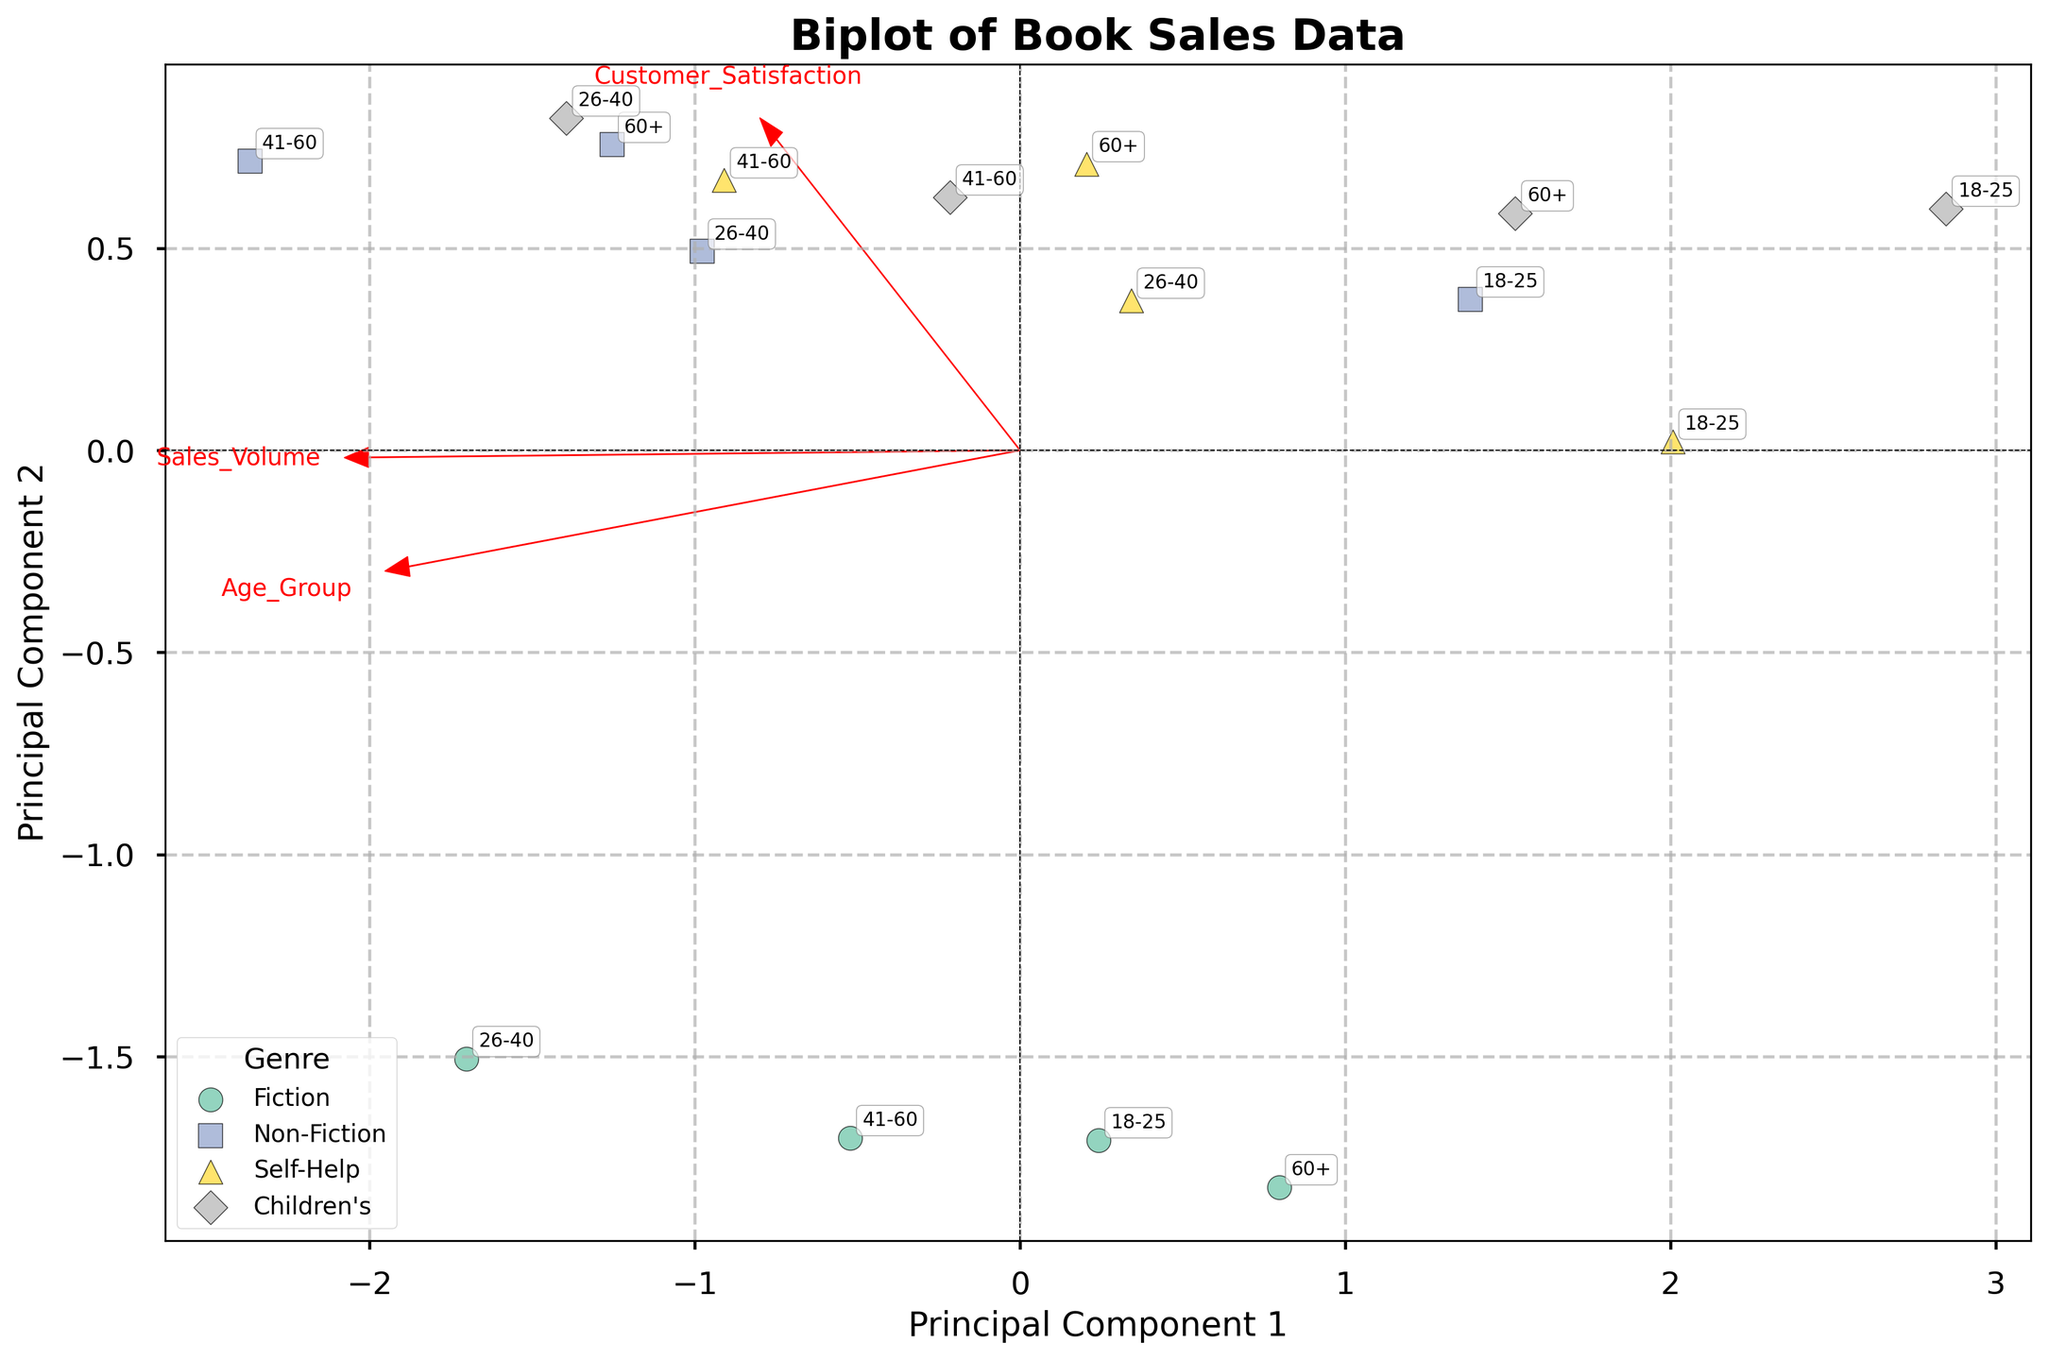What is the title of the plot? The title is located at the top center of the plot in larger, bold font. By reading it, we can directly obtain the title.
Answer: Biplot of Book Sales Data How many unique genres are represented in this plot? The legend on the plot shows each genre with a different color and marker. By counting them, we can determine the number of unique genres.
Answer: 4 Which genre appears to have the highest customer satisfaction across age groups? The position of points representing each genre in relation to the Customer_Satisfaction vector indicates its satisfaction level. The genre closest to the end of the Customer_Satisfaction arrow has the highest satisfaction.
Answer: Non-Fiction Which vector is more correlated with Principal Component 1? By observing the direction and length of the vectors, the one that aligns most closely with the horizontal axis, representing Principal Component 1, is more correlated.
Answer: Sales_Volume What age group is represented by the point closest to the origin? We can identify the point closest to the origin by looking for the one nearest to the intersection of the principal component axes, and then read the age group annotation next to that point.
Answer: 18-25 (Children's) Which age group shows greater sales volume for Fiction compared to 26-40 for Self-Help? By comparing the positions of Fiction and Self-Help points in relation to the Sales_Volume vector, we can determine which age group for Fiction is positioned further along the vector than 26-40 for Self-Help.
Answer: 26-40 (Fiction) What does the arrow representing Customer_Satisfaction indicate about its relationship to Educational_Value? The vectors representing Customer_Satisfaction and Educational_Value can be compared by their orientation. If they point in similar directions, it indicates they have a positive correlation.
Answer: Positive correlation Which data points suggest a lower educational value despite high customer satisfaction? Points far from the Educational_Value vector but near the Customer_Satisfaction vector suggest this trend. Identifying such points and then looking at their annotations indicates the respective genres and age groups.
Answer: Fiction (60+) Which genre and age group combination appears to have both high sales volume and high educational value? We look for points that are positioned high along both the Sales_Volume and Educational_Value vectors, and then check their genre and age group annotations.
Answer: Non-Fiction (41-60) Comparing 18-25 and 60+ age groups, which has higher customer satisfaction across all genres? By comparing the positions of these age groups in relation to the Customer_Satisfaction vector across different genres, we can deduce which has consistently higher satisfaction.
Answer: 60+ across most genres 